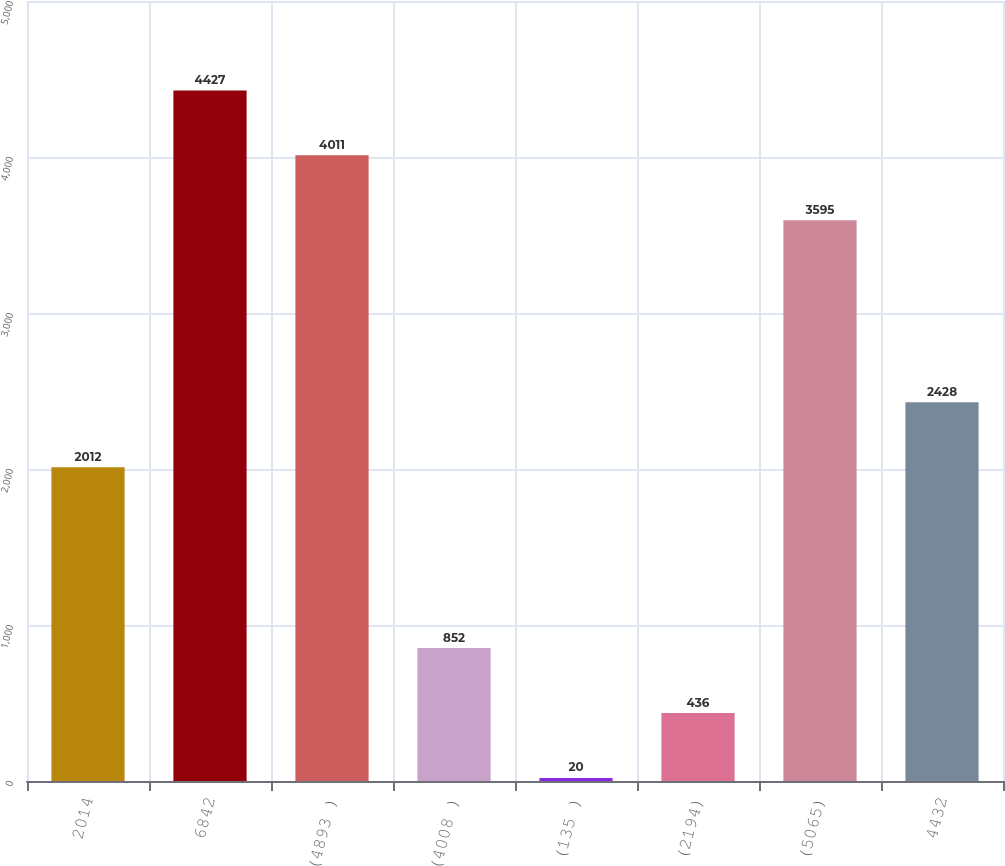<chart> <loc_0><loc_0><loc_500><loc_500><bar_chart><fcel>2014<fcel>6842<fcel>(4893 )<fcel>(4008 )<fcel>(135 )<fcel>(2194)<fcel>(5065)<fcel>4432<nl><fcel>2012<fcel>4427<fcel>4011<fcel>852<fcel>20<fcel>436<fcel>3595<fcel>2428<nl></chart> 